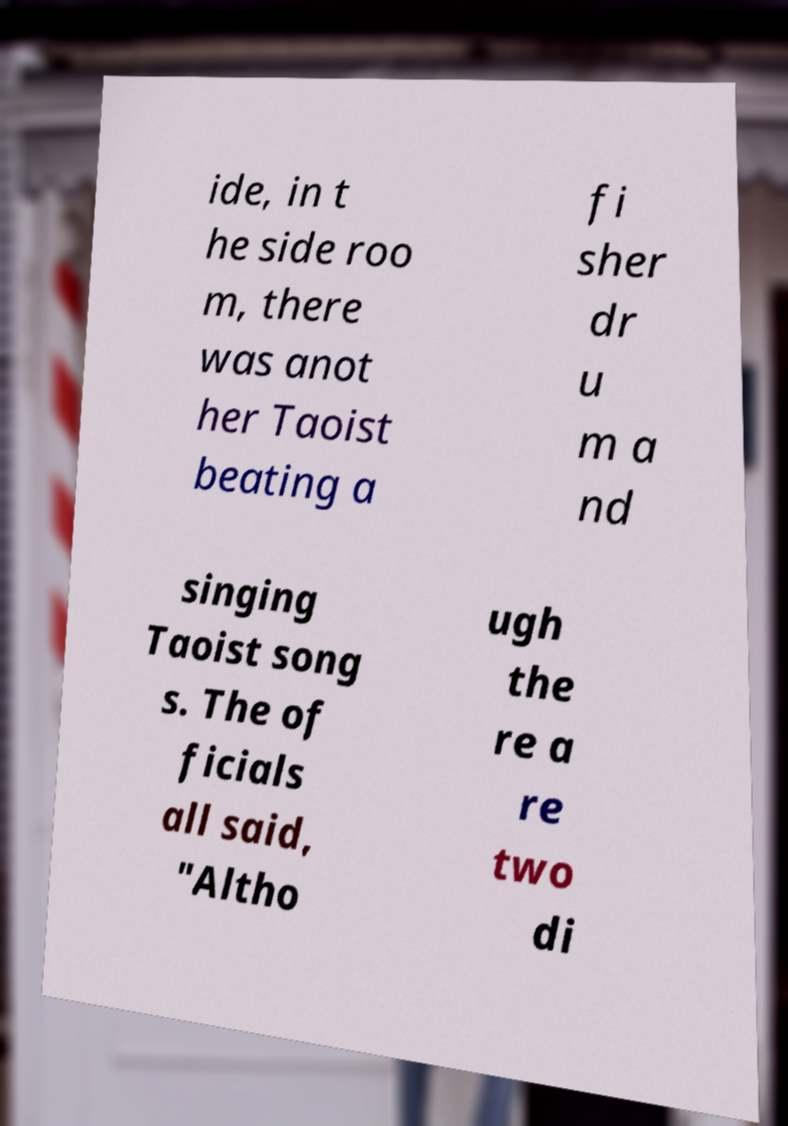Can you read and provide the text displayed in the image?This photo seems to have some interesting text. Can you extract and type it out for me? ide, in t he side roo m, there was anot her Taoist beating a fi sher dr u m a nd singing Taoist song s. The of ficials all said, "Altho ugh the re a re two di 